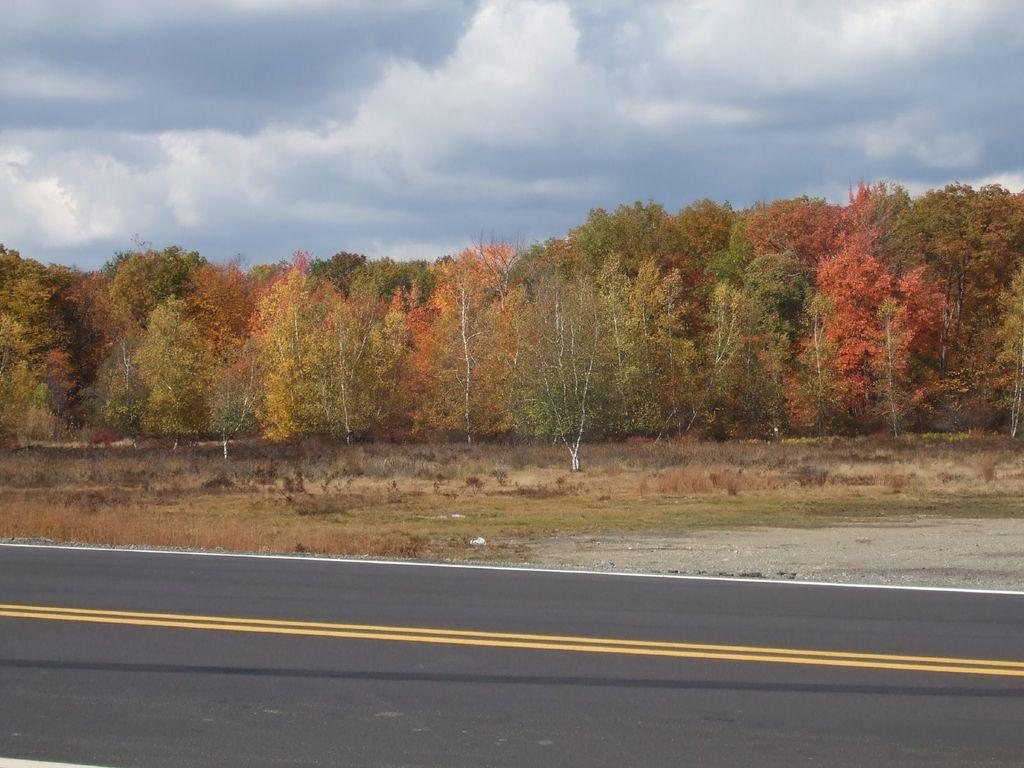What is the primary feature of the image? There are many trees in the image. What is located at the bottom of the image? There is a road at the bottom of the image. What can be seen in the sky at the top of the image? There are clouds in the sky at the top of the image. Where is the orange tree located in the image? There is no orange tree present in the image. Can you see a basketball game happening in the image? There is no basketball game or any reference to a basketball in the image. 